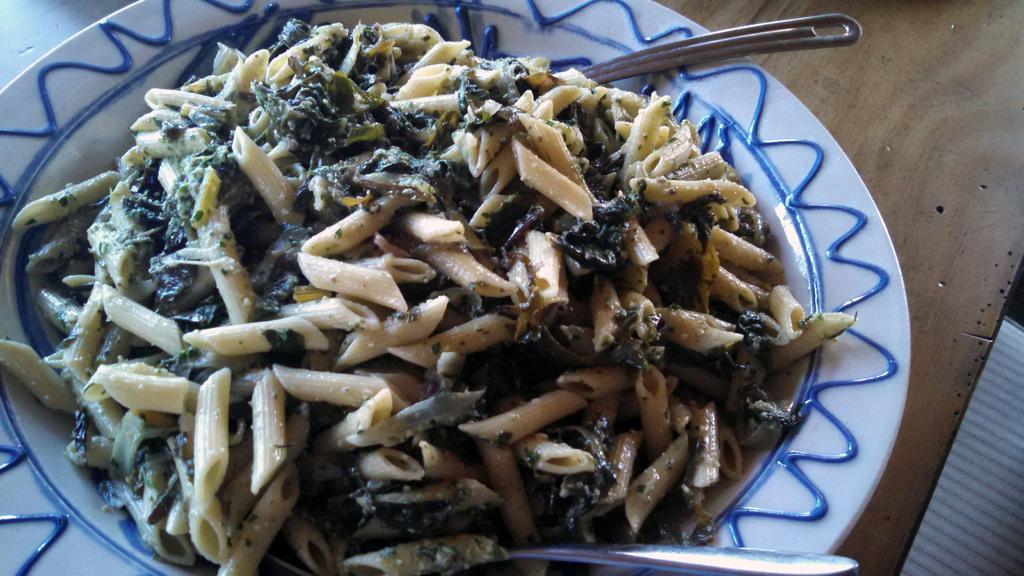How would you summarize this image in a sentence or two? In the foreground of this image, there is pasta and two spoons on a platter which is placed on the wooden surface. 